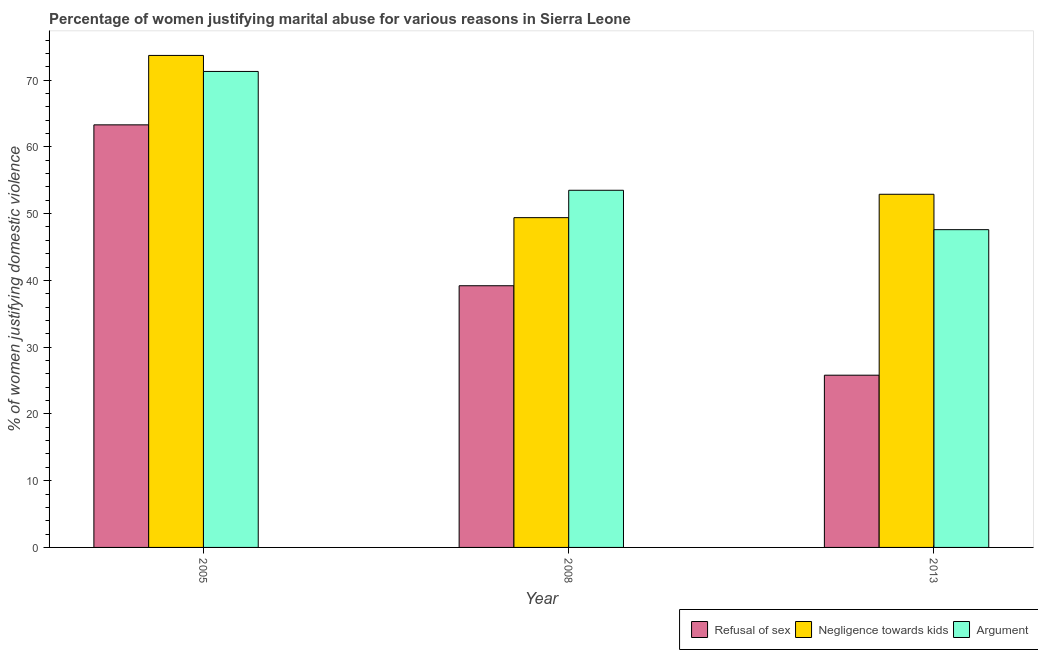Are the number of bars on each tick of the X-axis equal?
Give a very brief answer. Yes. How many bars are there on the 3rd tick from the left?
Your response must be concise. 3. How many bars are there on the 1st tick from the right?
Ensure brevity in your answer.  3. In how many cases, is the number of bars for a given year not equal to the number of legend labels?
Keep it short and to the point. 0. What is the percentage of women justifying domestic violence due to negligence towards kids in 2005?
Provide a succinct answer. 73.7. Across all years, what is the maximum percentage of women justifying domestic violence due to negligence towards kids?
Your answer should be very brief. 73.7. Across all years, what is the minimum percentage of women justifying domestic violence due to arguments?
Your response must be concise. 47.6. In which year was the percentage of women justifying domestic violence due to negligence towards kids minimum?
Offer a very short reply. 2008. What is the total percentage of women justifying domestic violence due to arguments in the graph?
Keep it short and to the point. 172.4. What is the difference between the percentage of women justifying domestic violence due to negligence towards kids in 2005 and that in 2013?
Give a very brief answer. 20.8. What is the difference between the percentage of women justifying domestic violence due to arguments in 2008 and the percentage of women justifying domestic violence due to negligence towards kids in 2005?
Your answer should be very brief. -17.8. What is the average percentage of women justifying domestic violence due to refusal of sex per year?
Give a very brief answer. 42.77. In the year 2013, what is the difference between the percentage of women justifying domestic violence due to arguments and percentage of women justifying domestic violence due to refusal of sex?
Provide a succinct answer. 0. What is the ratio of the percentage of women justifying domestic violence due to negligence towards kids in 2005 to that in 2008?
Provide a short and direct response. 1.49. Is the percentage of women justifying domestic violence due to negligence towards kids in 2005 less than that in 2013?
Make the answer very short. No. Is the difference between the percentage of women justifying domestic violence due to negligence towards kids in 2005 and 2008 greater than the difference between the percentage of women justifying domestic violence due to refusal of sex in 2005 and 2008?
Your answer should be very brief. No. What is the difference between the highest and the second highest percentage of women justifying domestic violence due to negligence towards kids?
Keep it short and to the point. 20.8. What is the difference between the highest and the lowest percentage of women justifying domestic violence due to refusal of sex?
Your answer should be compact. 37.5. Is the sum of the percentage of women justifying domestic violence due to refusal of sex in 2008 and 2013 greater than the maximum percentage of women justifying domestic violence due to negligence towards kids across all years?
Provide a succinct answer. Yes. What does the 2nd bar from the left in 2008 represents?
Your response must be concise. Negligence towards kids. What does the 1st bar from the right in 2008 represents?
Your answer should be very brief. Argument. How many bars are there?
Keep it short and to the point. 9. How many years are there in the graph?
Provide a short and direct response. 3. Are the values on the major ticks of Y-axis written in scientific E-notation?
Your response must be concise. No. Does the graph contain any zero values?
Keep it short and to the point. No. Where does the legend appear in the graph?
Provide a short and direct response. Bottom right. How many legend labels are there?
Give a very brief answer. 3. How are the legend labels stacked?
Give a very brief answer. Horizontal. What is the title of the graph?
Make the answer very short. Percentage of women justifying marital abuse for various reasons in Sierra Leone. Does "Ages 50+" appear as one of the legend labels in the graph?
Ensure brevity in your answer.  No. What is the label or title of the X-axis?
Offer a very short reply. Year. What is the label or title of the Y-axis?
Offer a very short reply. % of women justifying domestic violence. What is the % of women justifying domestic violence in Refusal of sex in 2005?
Provide a short and direct response. 63.3. What is the % of women justifying domestic violence of Negligence towards kids in 2005?
Offer a terse response. 73.7. What is the % of women justifying domestic violence of Argument in 2005?
Your answer should be very brief. 71.3. What is the % of women justifying domestic violence in Refusal of sex in 2008?
Offer a very short reply. 39.2. What is the % of women justifying domestic violence in Negligence towards kids in 2008?
Provide a short and direct response. 49.4. What is the % of women justifying domestic violence of Argument in 2008?
Your response must be concise. 53.5. What is the % of women justifying domestic violence in Refusal of sex in 2013?
Keep it short and to the point. 25.8. What is the % of women justifying domestic violence of Negligence towards kids in 2013?
Ensure brevity in your answer.  52.9. What is the % of women justifying domestic violence in Argument in 2013?
Provide a short and direct response. 47.6. Across all years, what is the maximum % of women justifying domestic violence in Refusal of sex?
Keep it short and to the point. 63.3. Across all years, what is the maximum % of women justifying domestic violence in Negligence towards kids?
Offer a very short reply. 73.7. Across all years, what is the maximum % of women justifying domestic violence in Argument?
Offer a terse response. 71.3. Across all years, what is the minimum % of women justifying domestic violence of Refusal of sex?
Your answer should be very brief. 25.8. Across all years, what is the minimum % of women justifying domestic violence in Negligence towards kids?
Provide a short and direct response. 49.4. Across all years, what is the minimum % of women justifying domestic violence in Argument?
Make the answer very short. 47.6. What is the total % of women justifying domestic violence of Refusal of sex in the graph?
Offer a terse response. 128.3. What is the total % of women justifying domestic violence in Negligence towards kids in the graph?
Your answer should be very brief. 176. What is the total % of women justifying domestic violence of Argument in the graph?
Make the answer very short. 172.4. What is the difference between the % of women justifying domestic violence of Refusal of sex in 2005 and that in 2008?
Ensure brevity in your answer.  24.1. What is the difference between the % of women justifying domestic violence in Negligence towards kids in 2005 and that in 2008?
Your response must be concise. 24.3. What is the difference between the % of women justifying domestic violence in Refusal of sex in 2005 and that in 2013?
Offer a very short reply. 37.5. What is the difference between the % of women justifying domestic violence of Negligence towards kids in 2005 and that in 2013?
Offer a terse response. 20.8. What is the difference between the % of women justifying domestic violence in Argument in 2005 and that in 2013?
Make the answer very short. 23.7. What is the difference between the % of women justifying domestic violence of Argument in 2008 and that in 2013?
Keep it short and to the point. 5.9. What is the difference between the % of women justifying domestic violence of Refusal of sex in 2005 and the % of women justifying domestic violence of Negligence towards kids in 2008?
Your response must be concise. 13.9. What is the difference between the % of women justifying domestic violence of Negligence towards kids in 2005 and the % of women justifying domestic violence of Argument in 2008?
Offer a very short reply. 20.2. What is the difference between the % of women justifying domestic violence of Refusal of sex in 2005 and the % of women justifying domestic violence of Negligence towards kids in 2013?
Offer a terse response. 10.4. What is the difference between the % of women justifying domestic violence in Refusal of sex in 2005 and the % of women justifying domestic violence in Argument in 2013?
Your answer should be compact. 15.7. What is the difference between the % of women justifying domestic violence in Negligence towards kids in 2005 and the % of women justifying domestic violence in Argument in 2013?
Your answer should be very brief. 26.1. What is the difference between the % of women justifying domestic violence of Refusal of sex in 2008 and the % of women justifying domestic violence of Negligence towards kids in 2013?
Your answer should be compact. -13.7. What is the difference between the % of women justifying domestic violence in Negligence towards kids in 2008 and the % of women justifying domestic violence in Argument in 2013?
Your answer should be very brief. 1.8. What is the average % of women justifying domestic violence in Refusal of sex per year?
Ensure brevity in your answer.  42.77. What is the average % of women justifying domestic violence of Negligence towards kids per year?
Give a very brief answer. 58.67. What is the average % of women justifying domestic violence of Argument per year?
Keep it short and to the point. 57.47. In the year 2005, what is the difference between the % of women justifying domestic violence of Refusal of sex and % of women justifying domestic violence of Negligence towards kids?
Your answer should be very brief. -10.4. In the year 2005, what is the difference between the % of women justifying domestic violence in Refusal of sex and % of women justifying domestic violence in Argument?
Offer a terse response. -8. In the year 2008, what is the difference between the % of women justifying domestic violence in Refusal of sex and % of women justifying domestic violence in Argument?
Your answer should be compact. -14.3. In the year 2008, what is the difference between the % of women justifying domestic violence of Negligence towards kids and % of women justifying domestic violence of Argument?
Your response must be concise. -4.1. In the year 2013, what is the difference between the % of women justifying domestic violence of Refusal of sex and % of women justifying domestic violence of Negligence towards kids?
Provide a succinct answer. -27.1. In the year 2013, what is the difference between the % of women justifying domestic violence in Refusal of sex and % of women justifying domestic violence in Argument?
Ensure brevity in your answer.  -21.8. In the year 2013, what is the difference between the % of women justifying domestic violence of Negligence towards kids and % of women justifying domestic violence of Argument?
Make the answer very short. 5.3. What is the ratio of the % of women justifying domestic violence of Refusal of sex in 2005 to that in 2008?
Provide a succinct answer. 1.61. What is the ratio of the % of women justifying domestic violence in Negligence towards kids in 2005 to that in 2008?
Your answer should be very brief. 1.49. What is the ratio of the % of women justifying domestic violence in Argument in 2005 to that in 2008?
Give a very brief answer. 1.33. What is the ratio of the % of women justifying domestic violence in Refusal of sex in 2005 to that in 2013?
Your response must be concise. 2.45. What is the ratio of the % of women justifying domestic violence of Negligence towards kids in 2005 to that in 2013?
Provide a short and direct response. 1.39. What is the ratio of the % of women justifying domestic violence of Argument in 2005 to that in 2013?
Your answer should be very brief. 1.5. What is the ratio of the % of women justifying domestic violence in Refusal of sex in 2008 to that in 2013?
Your answer should be very brief. 1.52. What is the ratio of the % of women justifying domestic violence in Negligence towards kids in 2008 to that in 2013?
Your answer should be very brief. 0.93. What is the ratio of the % of women justifying domestic violence in Argument in 2008 to that in 2013?
Provide a succinct answer. 1.12. What is the difference between the highest and the second highest % of women justifying domestic violence of Refusal of sex?
Provide a succinct answer. 24.1. What is the difference between the highest and the second highest % of women justifying domestic violence of Negligence towards kids?
Your response must be concise. 20.8. What is the difference between the highest and the lowest % of women justifying domestic violence in Refusal of sex?
Make the answer very short. 37.5. What is the difference between the highest and the lowest % of women justifying domestic violence of Negligence towards kids?
Give a very brief answer. 24.3. What is the difference between the highest and the lowest % of women justifying domestic violence of Argument?
Give a very brief answer. 23.7. 